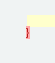<code> <loc_0><loc_0><loc_500><loc_500><_CSS_>}
</code> 